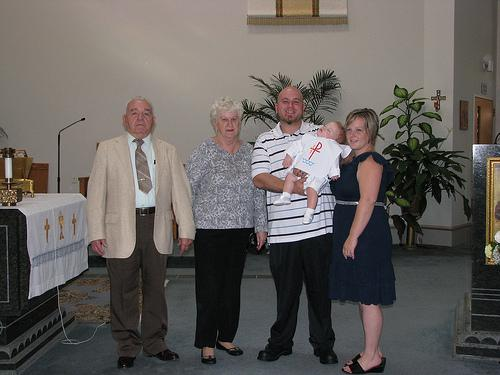Question: what color are the men's pants?
Choices:
A. Tan.
B. Grey.
C. Navy blue.
D. Brown and black.
Answer with the letter. Answer: D Question: why is the baby sleep?
Choices:
A. He is tired.
B. It is nighttime.
C. He is sick.
D. Him mom rocked him.
Answer with the letter. Answer: A Question: where does this picture take place?
Choices:
A. In a church.
B. In a courthouse.
C. In a cabin.
D. In a tent.
Answer with the letter. Answer: A Question: who is the man holding in his arms?
Choices:
A. A baby.
B. His daughter.
C. His little brother.
D. His niece.
Answer with the letter. Answer: A Question: how many people are in this picture?
Choices:
A. Five.
B. Six.
C. Seven.
D. Four.
Answer with the letter. Answer: A Question: when will the people leave the church?
Choices:
A. After the wedding.
B. After the sermon.
C. After they have finished getting the baby baptized.
D. After communion.
Answer with the letter. Answer: C Question: what color are the woman's pants?
Choices:
A. Tan.
B. Black.
C. Grey.
D. Navy blue.
Answer with the letter. Answer: B 